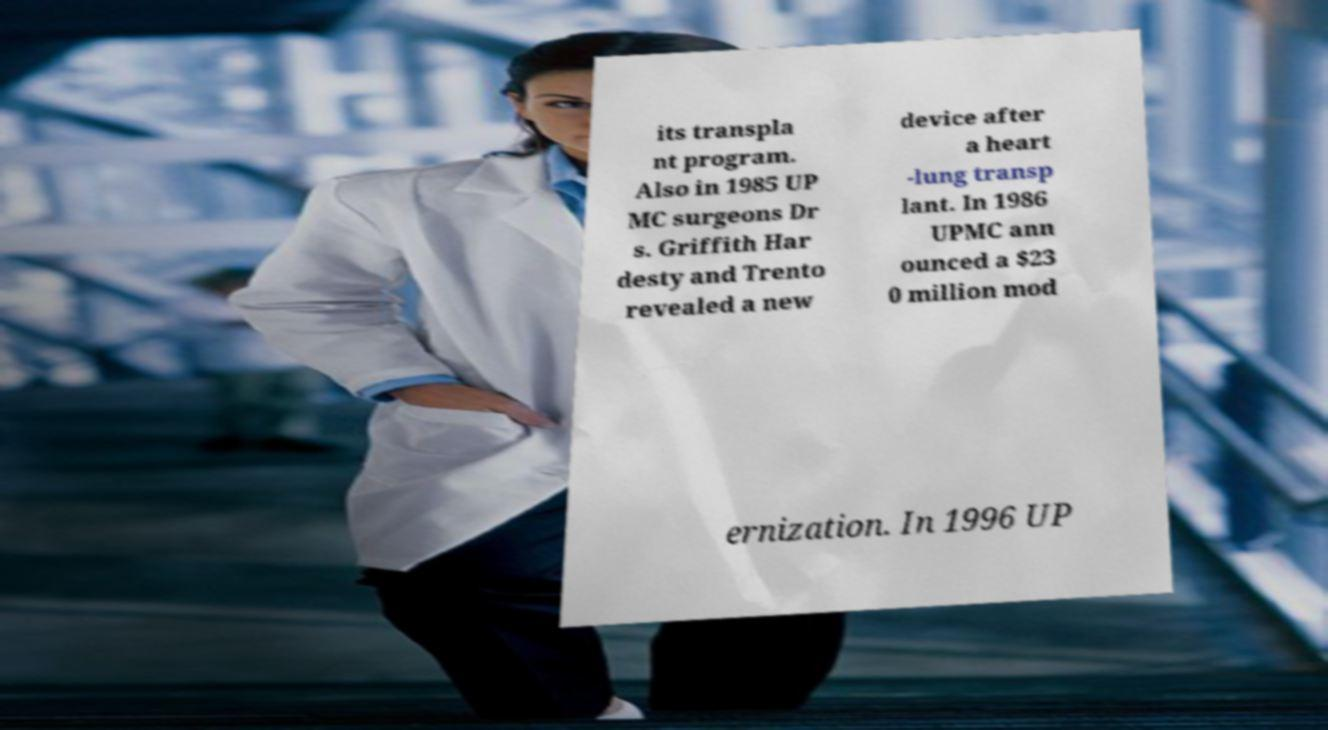What messages or text are displayed in this image? I need them in a readable, typed format. its transpla nt program. Also in 1985 UP MC surgeons Dr s. Griffith Har desty and Trento revealed a new device after a heart -lung transp lant. In 1986 UPMC ann ounced a $23 0 million mod ernization. In 1996 UP 